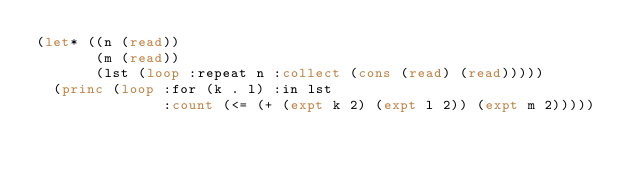<code> <loc_0><loc_0><loc_500><loc_500><_Lisp_>(let* ((n (read))
       (m (read))
       (lst (loop :repeat n :collect (cons (read) (read)))))
  (princ (loop :for (k . l) :in lst
               :count (<= (+ (expt k 2) (expt l 2)) (expt m 2)))))</code> 